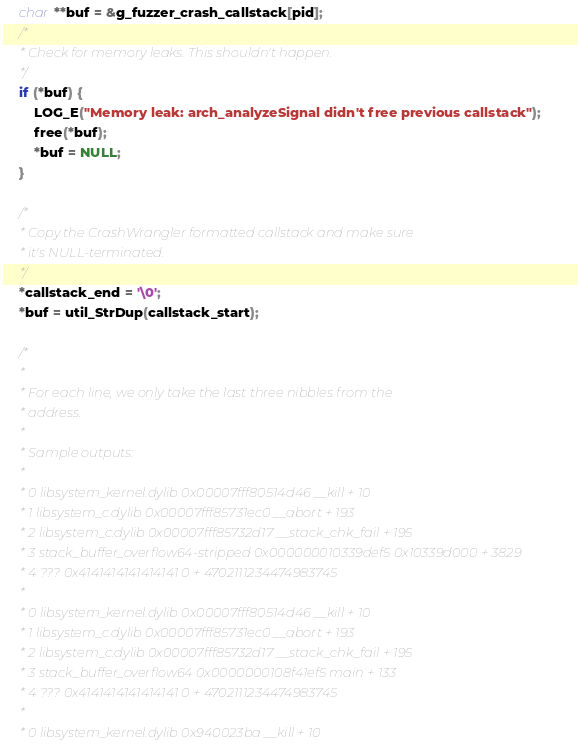Convert code to text. <code><loc_0><loc_0><loc_500><loc_500><_C_>    char **buf = &g_fuzzer_crash_callstack[pid];
    /*
     * Check for memory leaks. This shouldn't happen.
     */
    if (*buf) {
        LOG_E("Memory leak: arch_analyzeSignal didn't free previous callstack");
        free(*buf);
        *buf = NULL;
    }

    /*
     * Copy the CrashWrangler formatted callstack and make sure
     * it's NULL-terminated.
     */
    *callstack_end = '\0';
    *buf = util_StrDup(callstack_start);

    /*
     *
     * For each line, we only take the last three nibbles from the
     * address.
     *
     * Sample outputs:
     *
     * 0 libsystem_kernel.dylib 0x00007fff80514d46 __kill + 10
     * 1 libsystem_c.dylib 0x00007fff85731ec0 __abort + 193
     * 2 libsystem_c.dylib 0x00007fff85732d17 __stack_chk_fail + 195
     * 3 stack_buffer_overflow64-stripped 0x000000010339def5 0x10339d000 + 3829
     * 4 ??? 0x4141414141414141 0 + 4702111234474983745
     *
     * 0 libsystem_kernel.dylib 0x00007fff80514d46 __kill + 10
     * 1 libsystem_c.dylib 0x00007fff85731ec0 __abort + 193
     * 2 libsystem_c.dylib 0x00007fff85732d17 __stack_chk_fail + 195
     * 3 stack_buffer_overflow64 0x0000000108f41ef5 main + 133
     * 4 ??? 0x4141414141414141 0 + 4702111234474983745
     *
     * 0 libsystem_kernel.dylib 0x940023ba __kill + 10</code> 